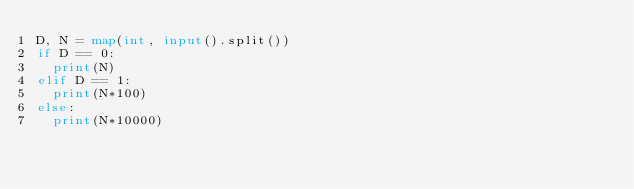Convert code to text. <code><loc_0><loc_0><loc_500><loc_500><_Python_>D, N = map(int, input().split())
if D == 0:
  print(N)
elif D == 1:
  print(N*100)
else:
  print(N*10000)</code> 